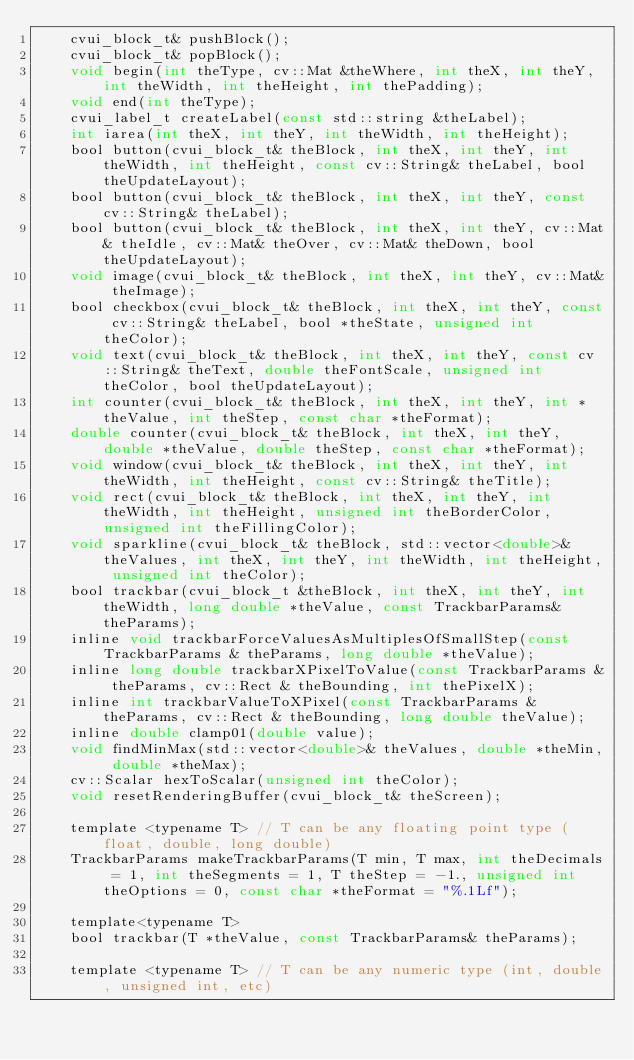Convert code to text. <code><loc_0><loc_0><loc_500><loc_500><_C_>	cvui_block_t& pushBlock();
	cvui_block_t& popBlock();
	void begin(int theType, cv::Mat &theWhere, int theX, int theY, int theWidth, int theHeight, int thePadding);
	void end(int theType);
	cvui_label_t createLabel(const std::string &theLabel);
	int iarea(int theX, int theY, int theWidth, int theHeight);
	bool button(cvui_block_t& theBlock, int theX, int theY, int theWidth, int theHeight, const cv::String& theLabel, bool theUpdateLayout);
	bool button(cvui_block_t& theBlock, int theX, int theY, const cv::String& theLabel);
	bool button(cvui_block_t& theBlock, int theX, int theY, cv::Mat& theIdle, cv::Mat& theOver, cv::Mat& theDown, bool theUpdateLayout);
	void image(cvui_block_t& theBlock, int theX, int theY, cv::Mat& theImage);
	bool checkbox(cvui_block_t& theBlock, int theX, int theY, const cv::String& theLabel, bool *theState, unsigned int theColor);
	void text(cvui_block_t& theBlock, int theX, int theY, const cv::String& theText, double theFontScale, unsigned int theColor, bool theUpdateLayout);
	int counter(cvui_block_t& theBlock, int theX, int theY, int *theValue, int theStep, const char *theFormat);
	double counter(cvui_block_t& theBlock, int theX, int theY, double *theValue, double theStep, const char *theFormat);
	void window(cvui_block_t& theBlock, int theX, int theY, int theWidth, int theHeight, const cv::String& theTitle);
	void rect(cvui_block_t& theBlock, int theX, int theY, int theWidth, int theHeight, unsigned int theBorderColor, unsigned int theFillingColor);
	void sparkline(cvui_block_t& theBlock, std::vector<double>& theValues, int theX, int theY, int theWidth, int theHeight, unsigned int theColor);
	bool trackbar(cvui_block_t &theBlock, int theX, int theY, int theWidth, long double *theValue, const TrackbarParams& theParams);
	inline void trackbarForceValuesAsMultiplesOfSmallStep(const TrackbarParams & theParams, long double *theValue);
	inline long double trackbarXPixelToValue(const TrackbarParams & theParams, cv::Rect & theBounding, int thePixelX);
	inline int trackbarValueToXPixel(const TrackbarParams & theParams, cv::Rect & theBounding, long double theValue);
	inline double clamp01(double value);
	void findMinMax(std::vector<double>& theValues, double *theMin, double *theMax);
	cv::Scalar hexToScalar(unsigned int theColor);
	void resetRenderingBuffer(cvui_block_t& theScreen);

	template <typename T> // T can be any floating point type (float, double, long double)
	TrackbarParams makeTrackbarParams(T min, T max, int theDecimals = 1, int theSegments = 1, T theStep = -1., unsigned int theOptions = 0, const char *theFormat = "%.1Lf");

	template<typename T>
	bool trackbar(T *theValue, const TrackbarParams& theParams);

	template <typename T> // T can be any numeric type (int, double, unsigned int, etc)</code> 